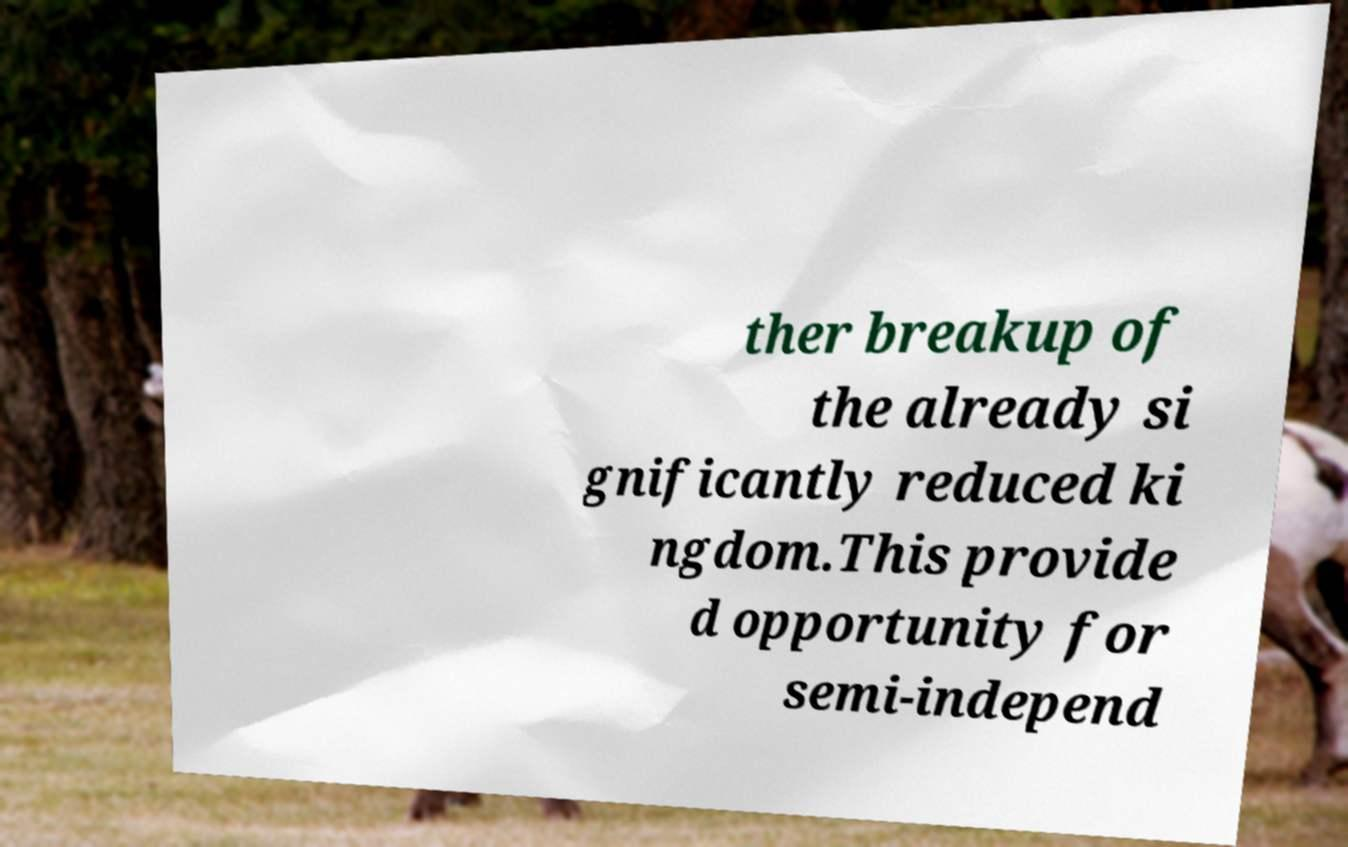Could you extract and type out the text from this image? ther breakup of the already si gnificantly reduced ki ngdom.This provide d opportunity for semi-independ 